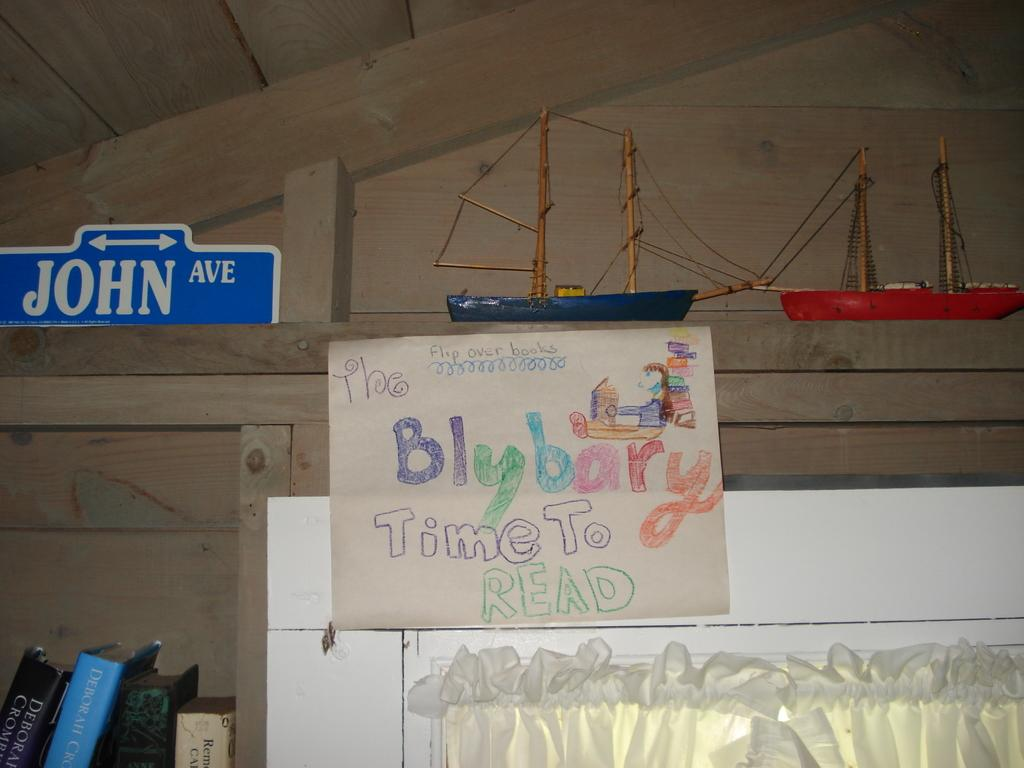<image>
Relay a brief, clear account of the picture shown. A hand-written poster reminds people that it's "time to read" 